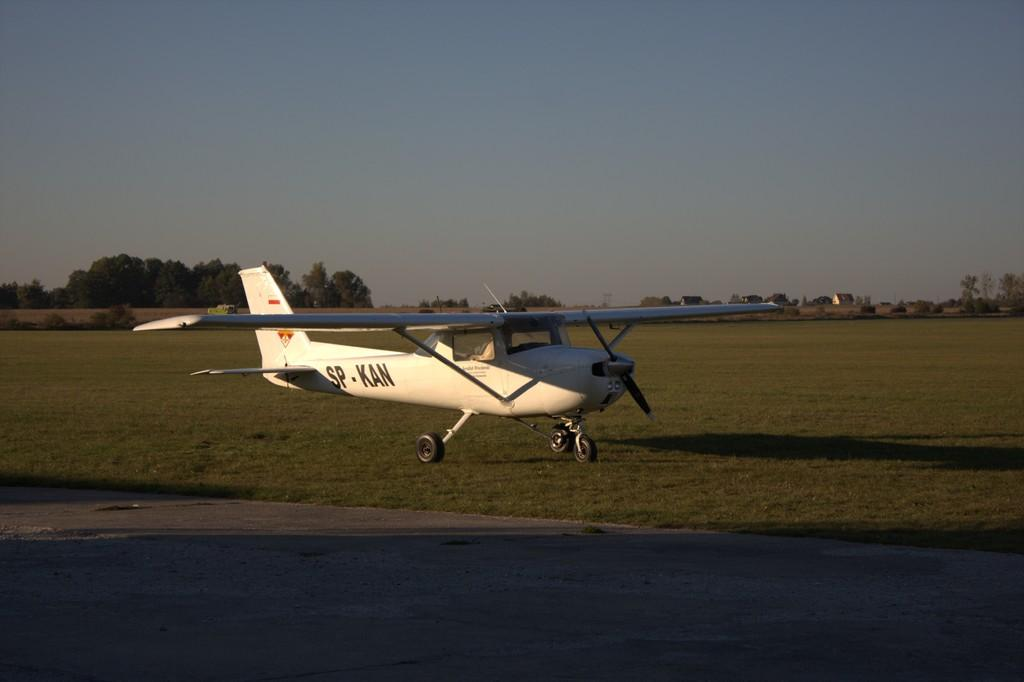Provide a one-sentence caption for the provided image. The word "SP-KAN" is painted on the side of the plane. 